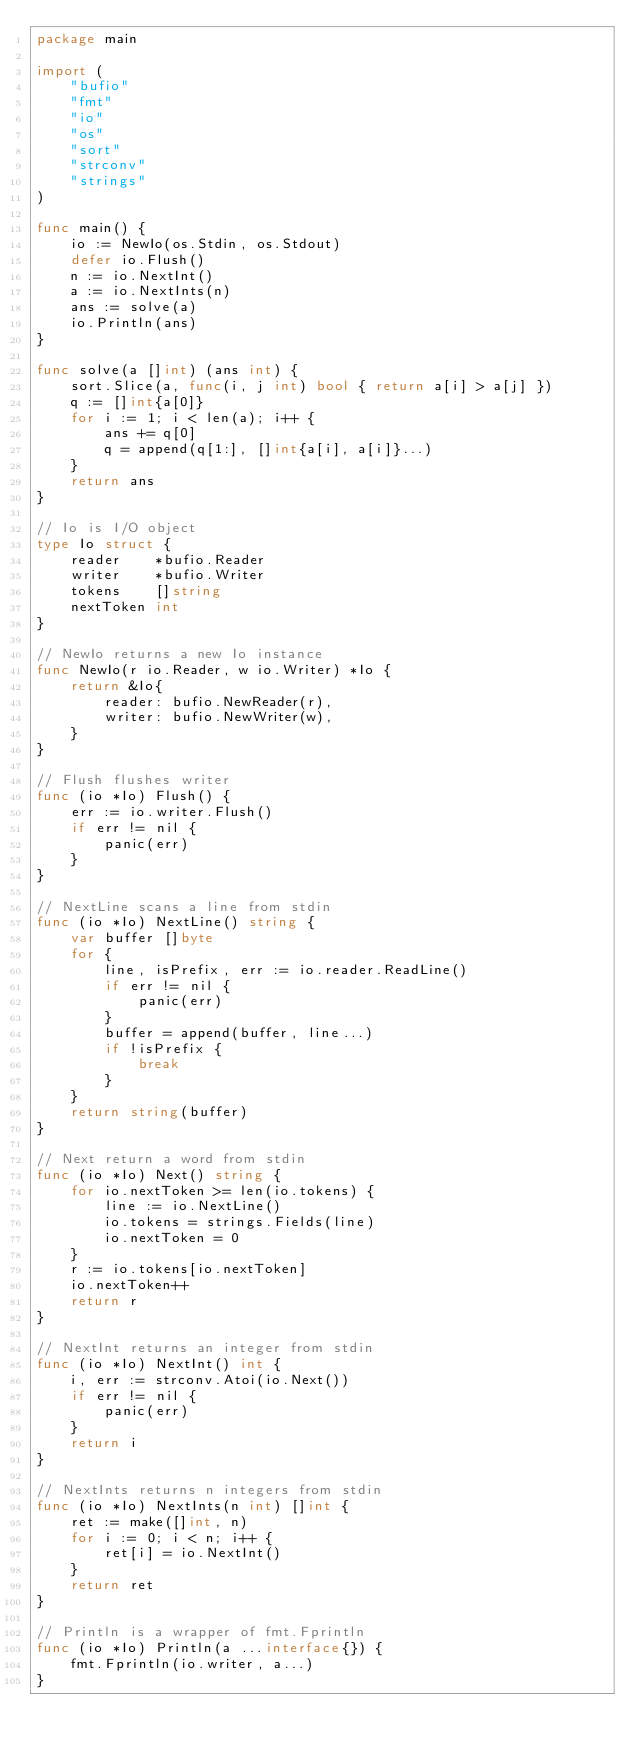Convert code to text. <code><loc_0><loc_0><loc_500><loc_500><_Go_>package main

import (
	"bufio"
	"fmt"
	"io"
	"os"
	"sort"
	"strconv"
	"strings"
)

func main() {
	io := NewIo(os.Stdin, os.Stdout)
	defer io.Flush()
	n := io.NextInt()
	a := io.NextInts(n)
	ans := solve(a)
	io.Println(ans)
}

func solve(a []int) (ans int) {
	sort.Slice(a, func(i, j int) bool { return a[i] > a[j] })
	q := []int{a[0]}
	for i := 1; i < len(a); i++ {
		ans += q[0]
		q = append(q[1:], []int{a[i], a[i]}...)
	}
	return ans
}

// Io is I/O object
type Io struct {
	reader    *bufio.Reader
	writer    *bufio.Writer
	tokens    []string
	nextToken int
}

// NewIo returns a new Io instance
func NewIo(r io.Reader, w io.Writer) *Io {
	return &Io{
		reader: bufio.NewReader(r),
		writer: bufio.NewWriter(w),
	}
}

// Flush flushes writer
func (io *Io) Flush() {
	err := io.writer.Flush()
	if err != nil {
		panic(err)
	}
}

// NextLine scans a line from stdin
func (io *Io) NextLine() string {
	var buffer []byte
	for {
		line, isPrefix, err := io.reader.ReadLine()
		if err != nil {
			panic(err)
		}
		buffer = append(buffer, line...)
		if !isPrefix {
			break
		}
	}
	return string(buffer)
}

// Next return a word from stdin
func (io *Io) Next() string {
	for io.nextToken >= len(io.tokens) {
		line := io.NextLine()
		io.tokens = strings.Fields(line)
		io.nextToken = 0
	}
	r := io.tokens[io.nextToken]
	io.nextToken++
	return r
}

// NextInt returns an integer from stdin
func (io *Io) NextInt() int {
	i, err := strconv.Atoi(io.Next())
	if err != nil {
		panic(err)
	}
	return i
}

// NextInts returns n integers from stdin
func (io *Io) NextInts(n int) []int {
	ret := make([]int, n)
	for i := 0; i < n; i++ {
		ret[i] = io.NextInt()
	}
	return ret
}

// Println is a wrapper of fmt.Fprintln
func (io *Io) Println(a ...interface{}) {
	fmt.Fprintln(io.writer, a...)
}
</code> 